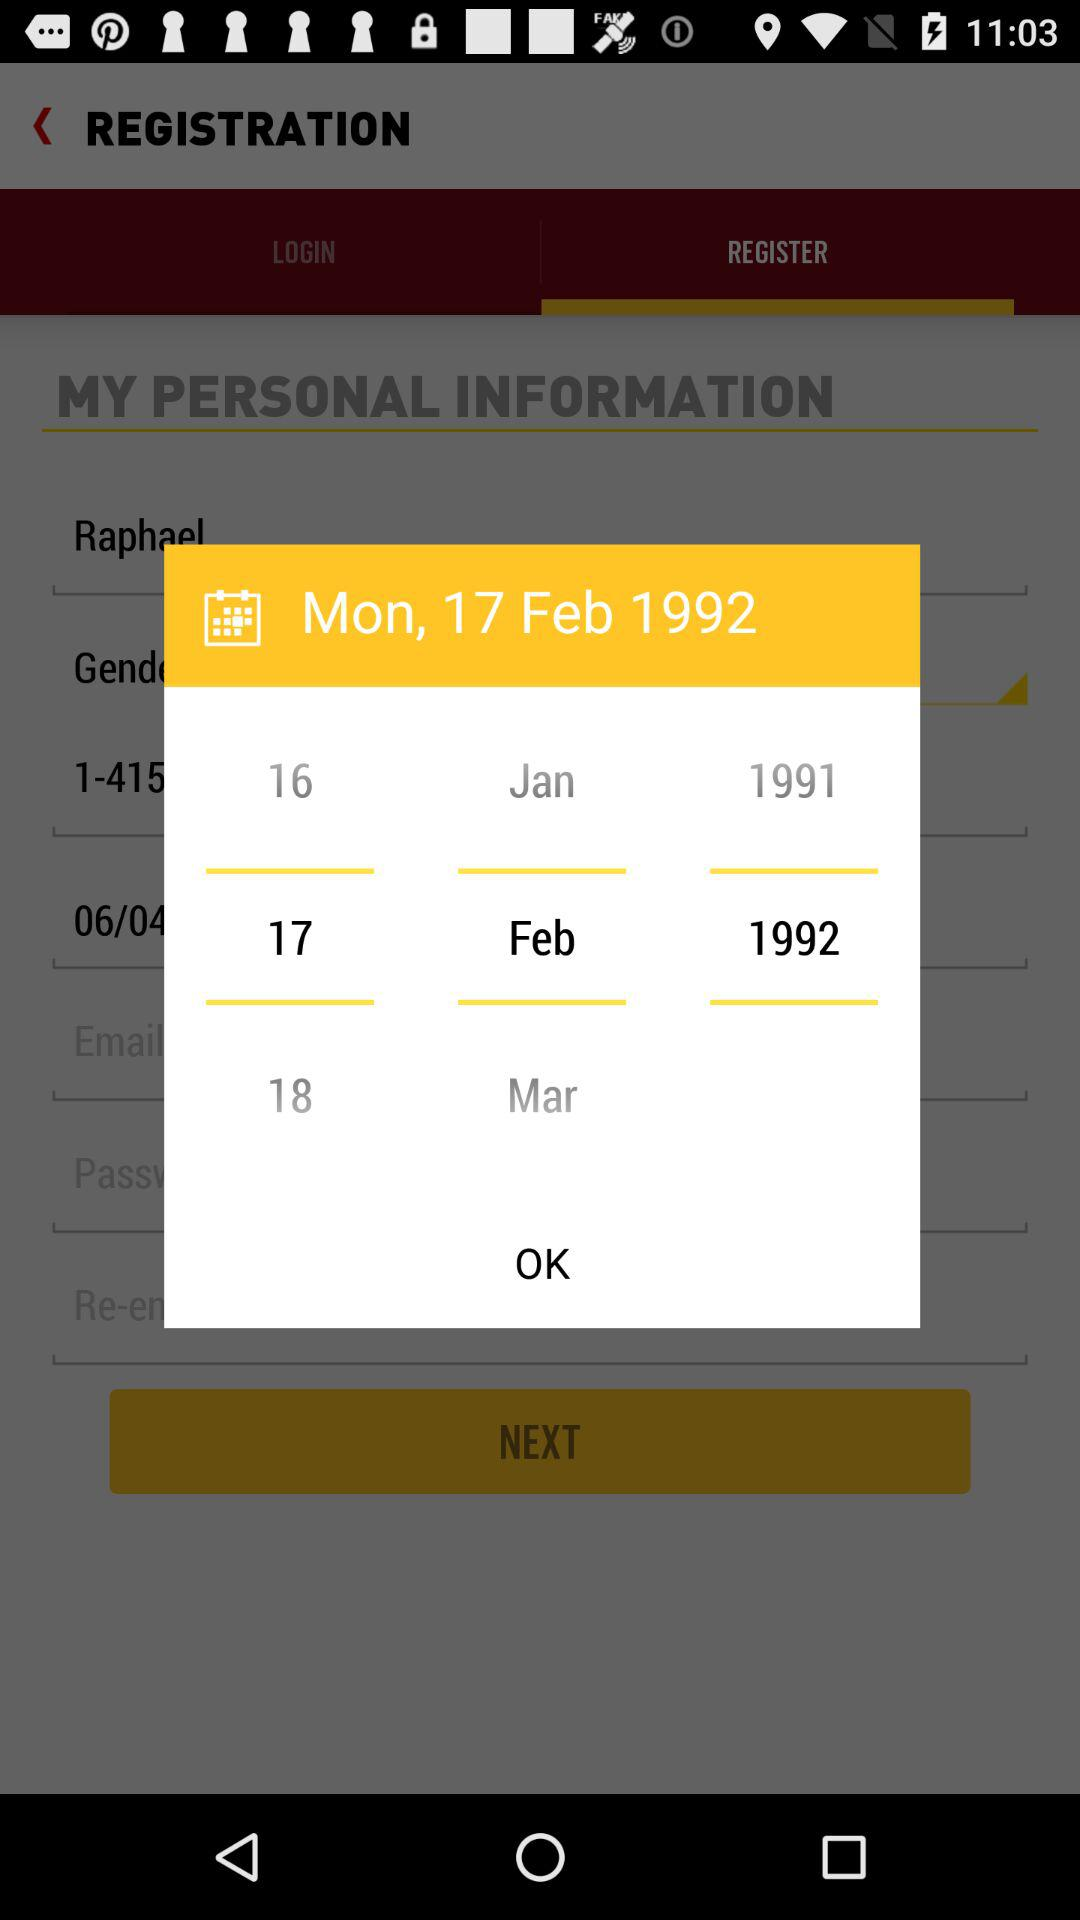Which date was selected? The selected date was Monday, February 17, 1992. 